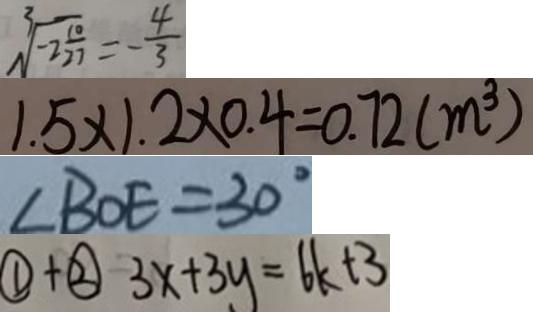<formula> <loc_0><loc_0><loc_500><loc_500>\sqrt [ 3 ] { - 2 \frac { 1 0 } { 2 7 } } = - \frac { 4 } { 3 } 
 1 . 5 \times 1 . 2 \times 0 . 4 = 0 . 7 2 ( m ^ { 3 } ) 
 \angle B O E = 3 0 ^ { \circ } 
 \textcircled { 1 } + \textcircled { 2 } 3 x + 3 y = 6 k + 3</formula> 